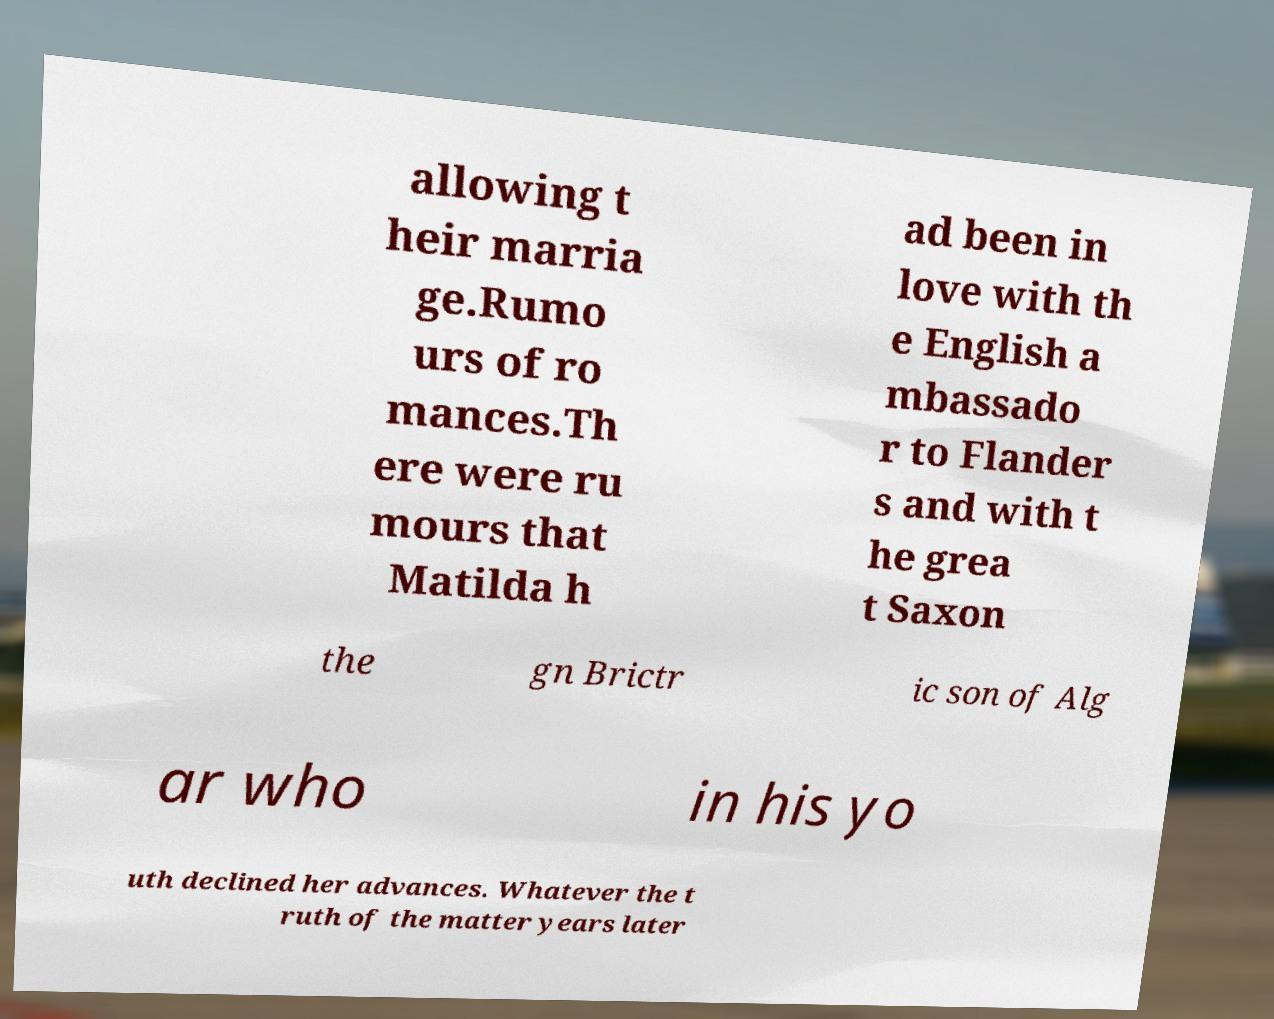I need the written content from this picture converted into text. Can you do that? allowing t heir marria ge.Rumo urs of ro mances.Th ere were ru mours that Matilda h ad been in love with th e English a mbassado r to Flander s and with t he grea t Saxon the gn Brictr ic son of Alg ar who in his yo uth declined her advances. Whatever the t ruth of the matter years later 